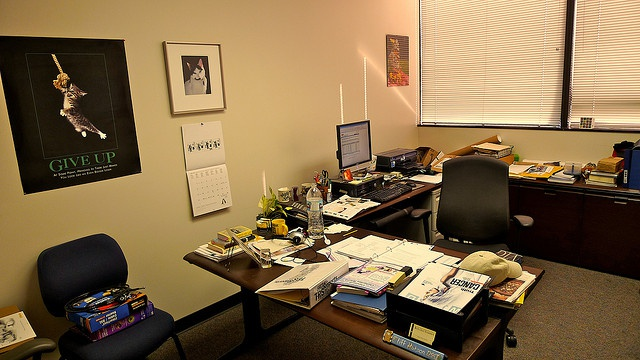Describe the objects in this image and their specific colors. I can see chair in olive, black, navy, tan, and maroon tones, chair in olive, black, maroon, and gray tones, book in olive, khaki, lightyellow, black, and darkgray tones, tv in olive, gray, and black tones, and book in olive, tan, darkgray, and beige tones in this image. 